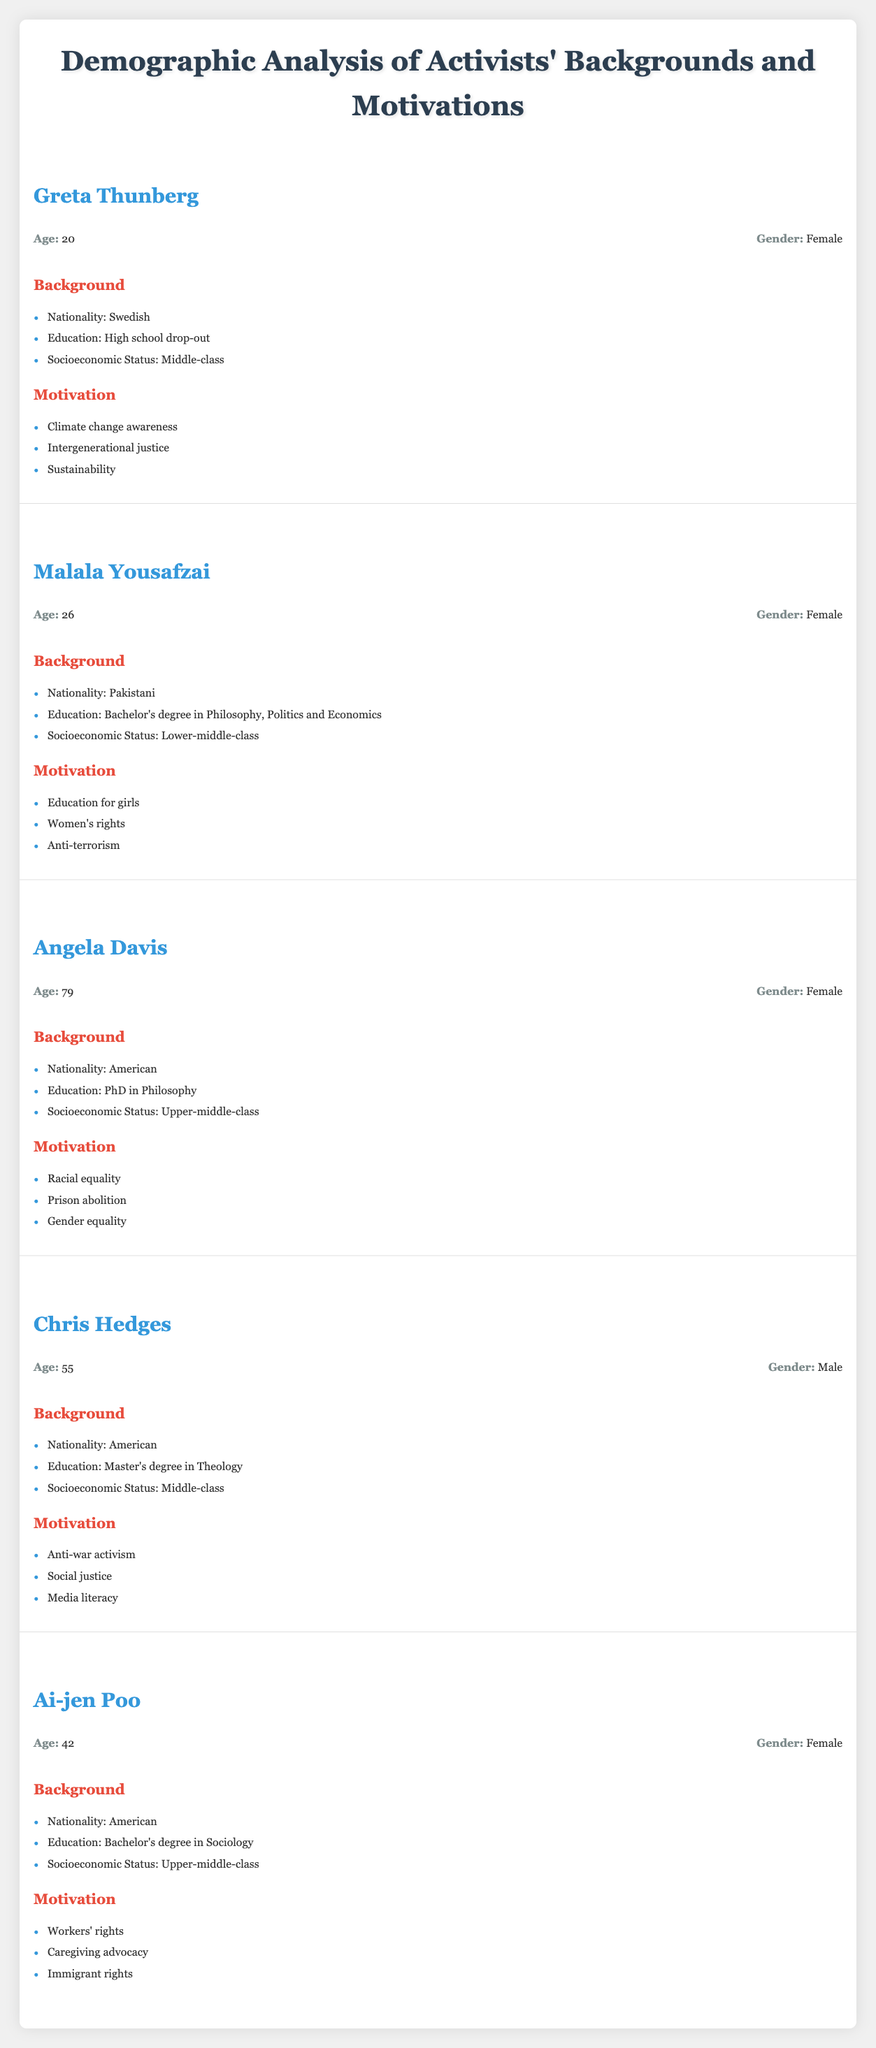What is the motivation of Greta Thunberg? According to the table, Greta Thunberg's motivations include "Climate change awareness," "Intergenerational justice," and "Sustainability." These aspects are listed under the "Motivation" section relevant to her.
Answer: Climate change awareness, Intergenerational justice, Sustainability What is the age of Angela Davis? The table indicates that Angela Davis is 79 years old, which is found next to her name in the "Age" section.
Answer: 79 How many activists have a bachelor's degree? By reviewing the education backgrounds, we find that Malala Yousafzai and Ai-jen Poo have bachelor's degrees, leading to a total of 2 activists with this level of education.
Answer: 2 Does Chris Hedges advocate for social justice? The table lists "Social justice" as one of Chris Hedges's motivations, therefore indicating that he indeed advocates for this cause.
Answer: Yes What is the average age of the activists listed? To find the average age, we first sum the ages of all activists (20 + 26 + 79 + 55 + 42 = 222). Then, we divide by the number of activists (5), resulting in an average age of 222/5 = 44.4.
Answer: 44.4 Which nationalities are represented among the activists? The activists come from three different nationalities: Swedish (Greta Thunberg), Pakistani (Malala Yousafzai), and American (Angela Davis, Chris Hedges, Ai-jen Poo). These are clearly indicated in the respective "Nationality" sections.
Answer: Swedish, Pakistani, American Are there any male activists in the table? The table shows that Chris Hedges is the only male activist listed, while all others (Greta Thunberg, Malala Yousafzai, Angela Davis, Ai-jen Poo) are female. Thus the answer is affirmative.
Answer: Yes What is the total number of motivations listed for Ai-jen Poo? Ai-jen Poo's motivations, which include "Workers' rights," "Caregiving advocacy," and "Immigrant rights," total 3. This count can be directly noted from her "Motivation" section.
Answer: 3 How many activists focus on women's rights? By reviewing the motivations, we find that both Malala Yousafzai and Ai-jen Poo emphasize women's rights as their key focus, thus there are a total of 2 activists concentrated on this issue.
Answer: 2 